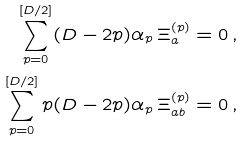<formula> <loc_0><loc_0><loc_500><loc_500>\sum _ { p = 0 } ^ { \left [ D / 2 \right ] } ( D - 2 p ) \alpha _ { p } \, \Xi _ { a } ^ { ( p ) } & = 0 \, , \\ \sum _ { p = 0 } ^ { \left [ D / 2 \right ] } p ( D - 2 p ) \alpha _ { p } \, \Xi _ { a b } ^ { ( p ) } & = 0 \, ,</formula> 